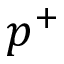<formula> <loc_0><loc_0><loc_500><loc_500>p ^ { + }</formula> 